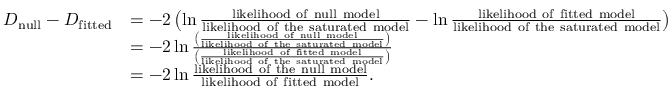Convert formula to latex. <formula><loc_0><loc_0><loc_500><loc_500>{ \begin{array} { r l } { D _ { n u l l } - D _ { f i t t e d } } & { = - 2 \left ( \ln { \frac { l i k e l i h o o d o f n u l l m o d e l } { l i k e l i h o o d o f t h e s a t u r a t e d m o d e l } } - \ln { \frac { l i k e l i h o o d o f f i t t e d m o d e l } { l i k e l i h o o d o f t h e s a t u r a t e d m o d e l } } \right ) } \\ & { = - 2 \ln { \frac { \left ( { \frac { l i k e l i h o o d o f n u l l m o d e l } { l i k e l i h o o d o f t h e s a t u r a t e d m o d e l } } \right ) } { \left ( { \frac { l i k e l i h o o d o f f i t t e d m o d e l } { l i k e l i h o o d o f t h e s a t u r a t e d m o d e l } } \right ) } } } \\ & { = - 2 \ln { \frac { l i k e l i h o o d o f t h e n u l l m o d e l } { l i k e l i h o o d o f f i t t e d m o d e l } } . } \end{array} }</formula> 